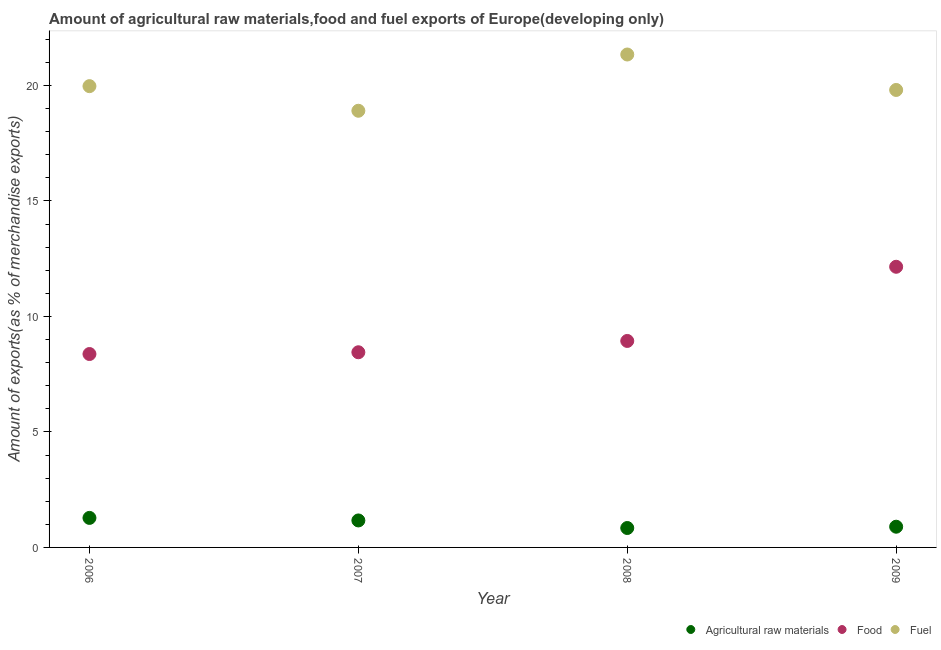Is the number of dotlines equal to the number of legend labels?
Provide a short and direct response. Yes. What is the percentage of food exports in 2009?
Your answer should be very brief. 12.15. Across all years, what is the maximum percentage of food exports?
Provide a succinct answer. 12.15. Across all years, what is the minimum percentage of food exports?
Ensure brevity in your answer.  8.37. In which year was the percentage of food exports maximum?
Your response must be concise. 2009. What is the total percentage of food exports in the graph?
Keep it short and to the point. 37.91. What is the difference between the percentage of food exports in 2006 and that in 2007?
Offer a very short reply. -0.08. What is the difference between the percentage of raw materials exports in 2006 and the percentage of fuel exports in 2008?
Keep it short and to the point. -20.06. What is the average percentage of raw materials exports per year?
Your answer should be compact. 1.05. In the year 2009, what is the difference between the percentage of fuel exports and percentage of raw materials exports?
Offer a very short reply. 18.91. In how many years, is the percentage of fuel exports greater than 18 %?
Your answer should be compact. 4. What is the ratio of the percentage of raw materials exports in 2007 to that in 2008?
Make the answer very short. 1.39. Is the percentage of food exports in 2008 less than that in 2009?
Provide a short and direct response. Yes. What is the difference between the highest and the second highest percentage of raw materials exports?
Your answer should be very brief. 0.11. What is the difference between the highest and the lowest percentage of fuel exports?
Your answer should be compact. 2.44. In how many years, is the percentage of food exports greater than the average percentage of food exports taken over all years?
Give a very brief answer. 1. Is the percentage of food exports strictly less than the percentage of fuel exports over the years?
Offer a terse response. Yes. Does the graph contain any zero values?
Ensure brevity in your answer.  No. Where does the legend appear in the graph?
Ensure brevity in your answer.  Bottom right. How many legend labels are there?
Your response must be concise. 3. How are the legend labels stacked?
Keep it short and to the point. Horizontal. What is the title of the graph?
Give a very brief answer. Amount of agricultural raw materials,food and fuel exports of Europe(developing only). Does "Errors" appear as one of the legend labels in the graph?
Make the answer very short. No. What is the label or title of the Y-axis?
Ensure brevity in your answer.  Amount of exports(as % of merchandise exports). What is the Amount of exports(as % of merchandise exports) in Agricultural raw materials in 2006?
Your answer should be very brief. 1.28. What is the Amount of exports(as % of merchandise exports) in Food in 2006?
Your response must be concise. 8.37. What is the Amount of exports(as % of merchandise exports) of Fuel in 2006?
Make the answer very short. 19.97. What is the Amount of exports(as % of merchandise exports) of Agricultural raw materials in 2007?
Give a very brief answer. 1.17. What is the Amount of exports(as % of merchandise exports) in Food in 2007?
Make the answer very short. 8.45. What is the Amount of exports(as % of merchandise exports) of Fuel in 2007?
Your answer should be compact. 18.9. What is the Amount of exports(as % of merchandise exports) in Agricultural raw materials in 2008?
Your answer should be very brief. 0.84. What is the Amount of exports(as % of merchandise exports) of Food in 2008?
Your response must be concise. 8.94. What is the Amount of exports(as % of merchandise exports) in Fuel in 2008?
Ensure brevity in your answer.  21.34. What is the Amount of exports(as % of merchandise exports) of Agricultural raw materials in 2009?
Keep it short and to the point. 0.9. What is the Amount of exports(as % of merchandise exports) of Food in 2009?
Offer a terse response. 12.15. What is the Amount of exports(as % of merchandise exports) of Fuel in 2009?
Keep it short and to the point. 19.81. Across all years, what is the maximum Amount of exports(as % of merchandise exports) in Agricultural raw materials?
Provide a succinct answer. 1.28. Across all years, what is the maximum Amount of exports(as % of merchandise exports) in Food?
Give a very brief answer. 12.15. Across all years, what is the maximum Amount of exports(as % of merchandise exports) of Fuel?
Provide a succinct answer. 21.34. Across all years, what is the minimum Amount of exports(as % of merchandise exports) of Agricultural raw materials?
Your answer should be compact. 0.84. Across all years, what is the minimum Amount of exports(as % of merchandise exports) in Food?
Give a very brief answer. 8.37. Across all years, what is the minimum Amount of exports(as % of merchandise exports) of Fuel?
Make the answer very short. 18.9. What is the total Amount of exports(as % of merchandise exports) of Agricultural raw materials in the graph?
Provide a succinct answer. 4.18. What is the total Amount of exports(as % of merchandise exports) of Food in the graph?
Your response must be concise. 37.91. What is the total Amount of exports(as % of merchandise exports) of Fuel in the graph?
Provide a short and direct response. 80.02. What is the difference between the Amount of exports(as % of merchandise exports) of Agricultural raw materials in 2006 and that in 2007?
Ensure brevity in your answer.  0.11. What is the difference between the Amount of exports(as % of merchandise exports) in Food in 2006 and that in 2007?
Your answer should be compact. -0.08. What is the difference between the Amount of exports(as % of merchandise exports) in Fuel in 2006 and that in 2007?
Offer a very short reply. 1.07. What is the difference between the Amount of exports(as % of merchandise exports) of Agricultural raw materials in 2006 and that in 2008?
Offer a terse response. 0.44. What is the difference between the Amount of exports(as % of merchandise exports) in Food in 2006 and that in 2008?
Give a very brief answer. -0.57. What is the difference between the Amount of exports(as % of merchandise exports) in Fuel in 2006 and that in 2008?
Your answer should be compact. -1.37. What is the difference between the Amount of exports(as % of merchandise exports) of Agricultural raw materials in 2006 and that in 2009?
Offer a terse response. 0.38. What is the difference between the Amount of exports(as % of merchandise exports) of Food in 2006 and that in 2009?
Your answer should be compact. -3.78. What is the difference between the Amount of exports(as % of merchandise exports) in Fuel in 2006 and that in 2009?
Ensure brevity in your answer.  0.17. What is the difference between the Amount of exports(as % of merchandise exports) of Agricultural raw materials in 2007 and that in 2008?
Give a very brief answer. 0.33. What is the difference between the Amount of exports(as % of merchandise exports) of Food in 2007 and that in 2008?
Make the answer very short. -0.49. What is the difference between the Amount of exports(as % of merchandise exports) in Fuel in 2007 and that in 2008?
Keep it short and to the point. -2.44. What is the difference between the Amount of exports(as % of merchandise exports) of Agricultural raw materials in 2007 and that in 2009?
Give a very brief answer. 0.27. What is the difference between the Amount of exports(as % of merchandise exports) of Food in 2007 and that in 2009?
Your response must be concise. -3.7. What is the difference between the Amount of exports(as % of merchandise exports) of Fuel in 2007 and that in 2009?
Offer a terse response. -0.9. What is the difference between the Amount of exports(as % of merchandise exports) of Agricultural raw materials in 2008 and that in 2009?
Provide a succinct answer. -0.06. What is the difference between the Amount of exports(as % of merchandise exports) in Food in 2008 and that in 2009?
Your answer should be very brief. -3.21. What is the difference between the Amount of exports(as % of merchandise exports) of Fuel in 2008 and that in 2009?
Make the answer very short. 1.54. What is the difference between the Amount of exports(as % of merchandise exports) of Agricultural raw materials in 2006 and the Amount of exports(as % of merchandise exports) of Food in 2007?
Give a very brief answer. -7.17. What is the difference between the Amount of exports(as % of merchandise exports) of Agricultural raw materials in 2006 and the Amount of exports(as % of merchandise exports) of Fuel in 2007?
Keep it short and to the point. -17.63. What is the difference between the Amount of exports(as % of merchandise exports) of Food in 2006 and the Amount of exports(as % of merchandise exports) of Fuel in 2007?
Offer a very short reply. -10.53. What is the difference between the Amount of exports(as % of merchandise exports) of Agricultural raw materials in 2006 and the Amount of exports(as % of merchandise exports) of Food in 2008?
Keep it short and to the point. -7.66. What is the difference between the Amount of exports(as % of merchandise exports) of Agricultural raw materials in 2006 and the Amount of exports(as % of merchandise exports) of Fuel in 2008?
Provide a succinct answer. -20.06. What is the difference between the Amount of exports(as % of merchandise exports) in Food in 2006 and the Amount of exports(as % of merchandise exports) in Fuel in 2008?
Keep it short and to the point. -12.97. What is the difference between the Amount of exports(as % of merchandise exports) of Agricultural raw materials in 2006 and the Amount of exports(as % of merchandise exports) of Food in 2009?
Give a very brief answer. -10.87. What is the difference between the Amount of exports(as % of merchandise exports) of Agricultural raw materials in 2006 and the Amount of exports(as % of merchandise exports) of Fuel in 2009?
Keep it short and to the point. -18.53. What is the difference between the Amount of exports(as % of merchandise exports) of Food in 2006 and the Amount of exports(as % of merchandise exports) of Fuel in 2009?
Keep it short and to the point. -11.43. What is the difference between the Amount of exports(as % of merchandise exports) in Agricultural raw materials in 2007 and the Amount of exports(as % of merchandise exports) in Food in 2008?
Make the answer very short. -7.77. What is the difference between the Amount of exports(as % of merchandise exports) of Agricultural raw materials in 2007 and the Amount of exports(as % of merchandise exports) of Fuel in 2008?
Your answer should be compact. -20.17. What is the difference between the Amount of exports(as % of merchandise exports) in Food in 2007 and the Amount of exports(as % of merchandise exports) in Fuel in 2008?
Your response must be concise. -12.89. What is the difference between the Amount of exports(as % of merchandise exports) in Agricultural raw materials in 2007 and the Amount of exports(as % of merchandise exports) in Food in 2009?
Ensure brevity in your answer.  -10.98. What is the difference between the Amount of exports(as % of merchandise exports) in Agricultural raw materials in 2007 and the Amount of exports(as % of merchandise exports) in Fuel in 2009?
Provide a short and direct response. -18.64. What is the difference between the Amount of exports(as % of merchandise exports) in Food in 2007 and the Amount of exports(as % of merchandise exports) in Fuel in 2009?
Give a very brief answer. -11.36. What is the difference between the Amount of exports(as % of merchandise exports) in Agricultural raw materials in 2008 and the Amount of exports(as % of merchandise exports) in Food in 2009?
Offer a terse response. -11.31. What is the difference between the Amount of exports(as % of merchandise exports) of Agricultural raw materials in 2008 and the Amount of exports(as % of merchandise exports) of Fuel in 2009?
Provide a short and direct response. -18.96. What is the difference between the Amount of exports(as % of merchandise exports) of Food in 2008 and the Amount of exports(as % of merchandise exports) of Fuel in 2009?
Give a very brief answer. -10.87. What is the average Amount of exports(as % of merchandise exports) in Agricultural raw materials per year?
Offer a very short reply. 1.05. What is the average Amount of exports(as % of merchandise exports) in Food per year?
Make the answer very short. 9.48. What is the average Amount of exports(as % of merchandise exports) in Fuel per year?
Your response must be concise. 20.01. In the year 2006, what is the difference between the Amount of exports(as % of merchandise exports) in Agricultural raw materials and Amount of exports(as % of merchandise exports) in Food?
Provide a succinct answer. -7.1. In the year 2006, what is the difference between the Amount of exports(as % of merchandise exports) in Agricultural raw materials and Amount of exports(as % of merchandise exports) in Fuel?
Provide a short and direct response. -18.69. In the year 2006, what is the difference between the Amount of exports(as % of merchandise exports) of Food and Amount of exports(as % of merchandise exports) of Fuel?
Ensure brevity in your answer.  -11.6. In the year 2007, what is the difference between the Amount of exports(as % of merchandise exports) in Agricultural raw materials and Amount of exports(as % of merchandise exports) in Food?
Keep it short and to the point. -7.28. In the year 2007, what is the difference between the Amount of exports(as % of merchandise exports) of Agricultural raw materials and Amount of exports(as % of merchandise exports) of Fuel?
Give a very brief answer. -17.74. In the year 2007, what is the difference between the Amount of exports(as % of merchandise exports) in Food and Amount of exports(as % of merchandise exports) in Fuel?
Your answer should be very brief. -10.46. In the year 2008, what is the difference between the Amount of exports(as % of merchandise exports) in Agricultural raw materials and Amount of exports(as % of merchandise exports) in Food?
Provide a succinct answer. -8.1. In the year 2008, what is the difference between the Amount of exports(as % of merchandise exports) of Agricultural raw materials and Amount of exports(as % of merchandise exports) of Fuel?
Provide a succinct answer. -20.5. In the year 2008, what is the difference between the Amount of exports(as % of merchandise exports) of Food and Amount of exports(as % of merchandise exports) of Fuel?
Provide a short and direct response. -12.4. In the year 2009, what is the difference between the Amount of exports(as % of merchandise exports) in Agricultural raw materials and Amount of exports(as % of merchandise exports) in Food?
Your response must be concise. -11.25. In the year 2009, what is the difference between the Amount of exports(as % of merchandise exports) of Agricultural raw materials and Amount of exports(as % of merchandise exports) of Fuel?
Offer a terse response. -18.91. In the year 2009, what is the difference between the Amount of exports(as % of merchandise exports) of Food and Amount of exports(as % of merchandise exports) of Fuel?
Your response must be concise. -7.66. What is the ratio of the Amount of exports(as % of merchandise exports) of Agricultural raw materials in 2006 to that in 2007?
Provide a succinct answer. 1.09. What is the ratio of the Amount of exports(as % of merchandise exports) in Fuel in 2006 to that in 2007?
Provide a short and direct response. 1.06. What is the ratio of the Amount of exports(as % of merchandise exports) of Agricultural raw materials in 2006 to that in 2008?
Make the answer very short. 1.52. What is the ratio of the Amount of exports(as % of merchandise exports) of Food in 2006 to that in 2008?
Your response must be concise. 0.94. What is the ratio of the Amount of exports(as % of merchandise exports) in Fuel in 2006 to that in 2008?
Provide a succinct answer. 0.94. What is the ratio of the Amount of exports(as % of merchandise exports) in Agricultural raw materials in 2006 to that in 2009?
Your response must be concise. 1.43. What is the ratio of the Amount of exports(as % of merchandise exports) in Food in 2006 to that in 2009?
Offer a very short reply. 0.69. What is the ratio of the Amount of exports(as % of merchandise exports) in Fuel in 2006 to that in 2009?
Offer a very short reply. 1.01. What is the ratio of the Amount of exports(as % of merchandise exports) in Agricultural raw materials in 2007 to that in 2008?
Offer a very short reply. 1.39. What is the ratio of the Amount of exports(as % of merchandise exports) of Food in 2007 to that in 2008?
Offer a very short reply. 0.95. What is the ratio of the Amount of exports(as % of merchandise exports) in Fuel in 2007 to that in 2008?
Give a very brief answer. 0.89. What is the ratio of the Amount of exports(as % of merchandise exports) of Agricultural raw materials in 2007 to that in 2009?
Your answer should be very brief. 1.3. What is the ratio of the Amount of exports(as % of merchandise exports) of Food in 2007 to that in 2009?
Provide a short and direct response. 0.7. What is the ratio of the Amount of exports(as % of merchandise exports) in Fuel in 2007 to that in 2009?
Give a very brief answer. 0.95. What is the ratio of the Amount of exports(as % of merchandise exports) of Agricultural raw materials in 2008 to that in 2009?
Give a very brief answer. 0.94. What is the ratio of the Amount of exports(as % of merchandise exports) of Food in 2008 to that in 2009?
Your answer should be very brief. 0.74. What is the ratio of the Amount of exports(as % of merchandise exports) of Fuel in 2008 to that in 2009?
Your answer should be very brief. 1.08. What is the difference between the highest and the second highest Amount of exports(as % of merchandise exports) in Agricultural raw materials?
Keep it short and to the point. 0.11. What is the difference between the highest and the second highest Amount of exports(as % of merchandise exports) of Food?
Your answer should be very brief. 3.21. What is the difference between the highest and the second highest Amount of exports(as % of merchandise exports) of Fuel?
Keep it short and to the point. 1.37. What is the difference between the highest and the lowest Amount of exports(as % of merchandise exports) of Agricultural raw materials?
Your answer should be compact. 0.44. What is the difference between the highest and the lowest Amount of exports(as % of merchandise exports) of Food?
Ensure brevity in your answer.  3.78. What is the difference between the highest and the lowest Amount of exports(as % of merchandise exports) of Fuel?
Your response must be concise. 2.44. 